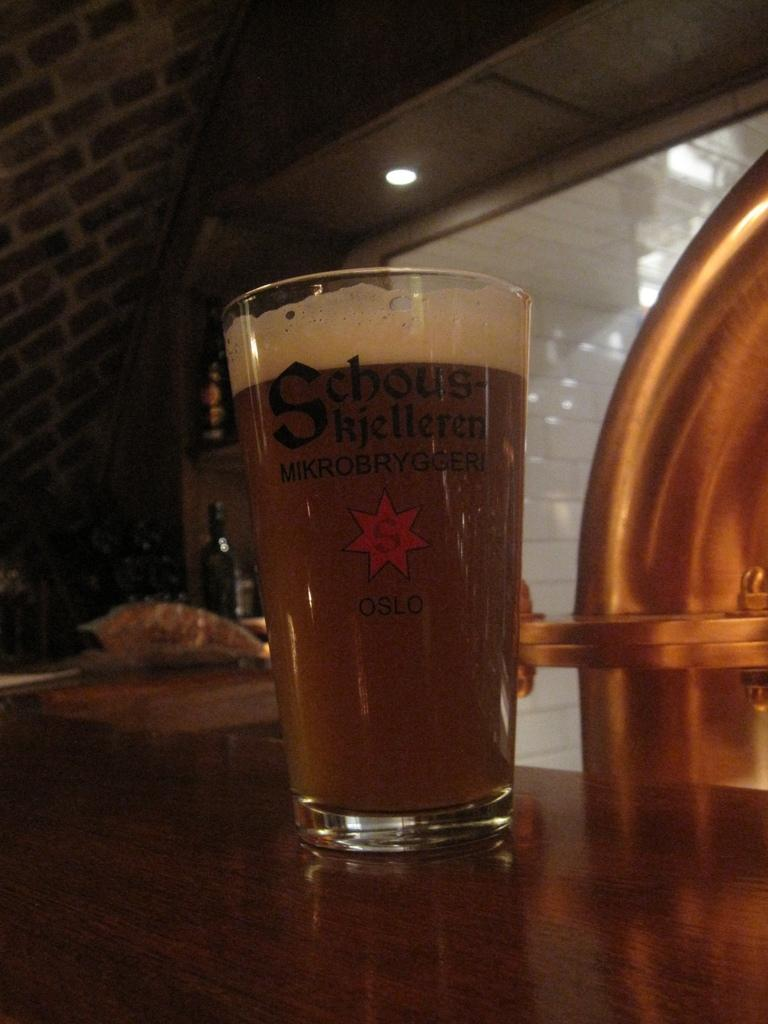<image>
Provide a brief description of the given image. A glass of what looks like beer with Oslo written on it 